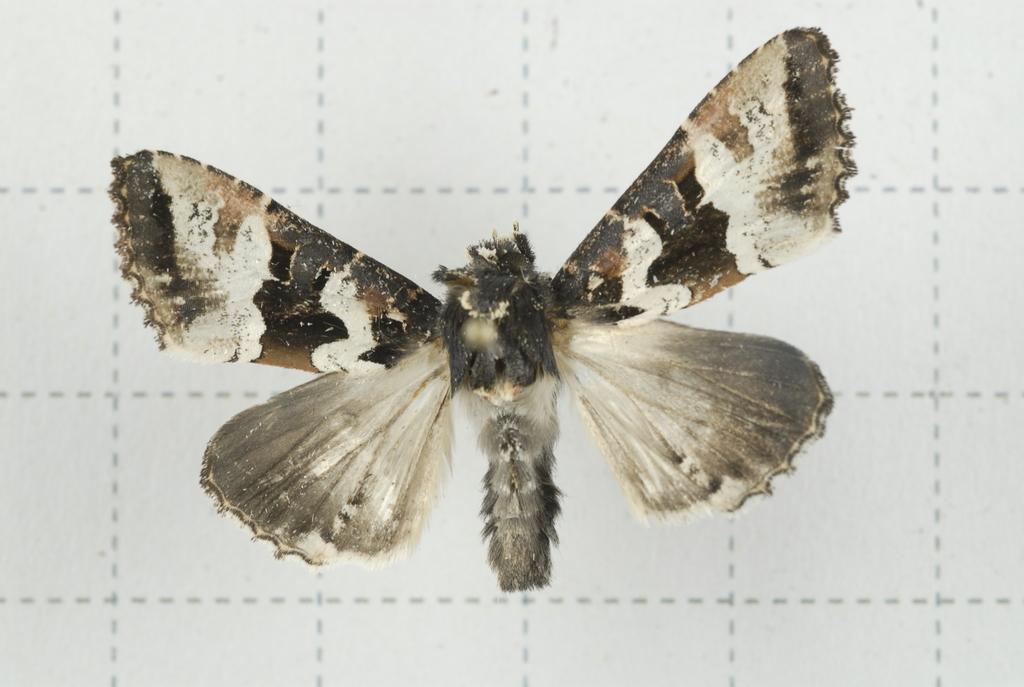Could you give a brief overview of what you see in this image? In this picture we can see the white color butterfly in the front. Behind there is a white paper background. 